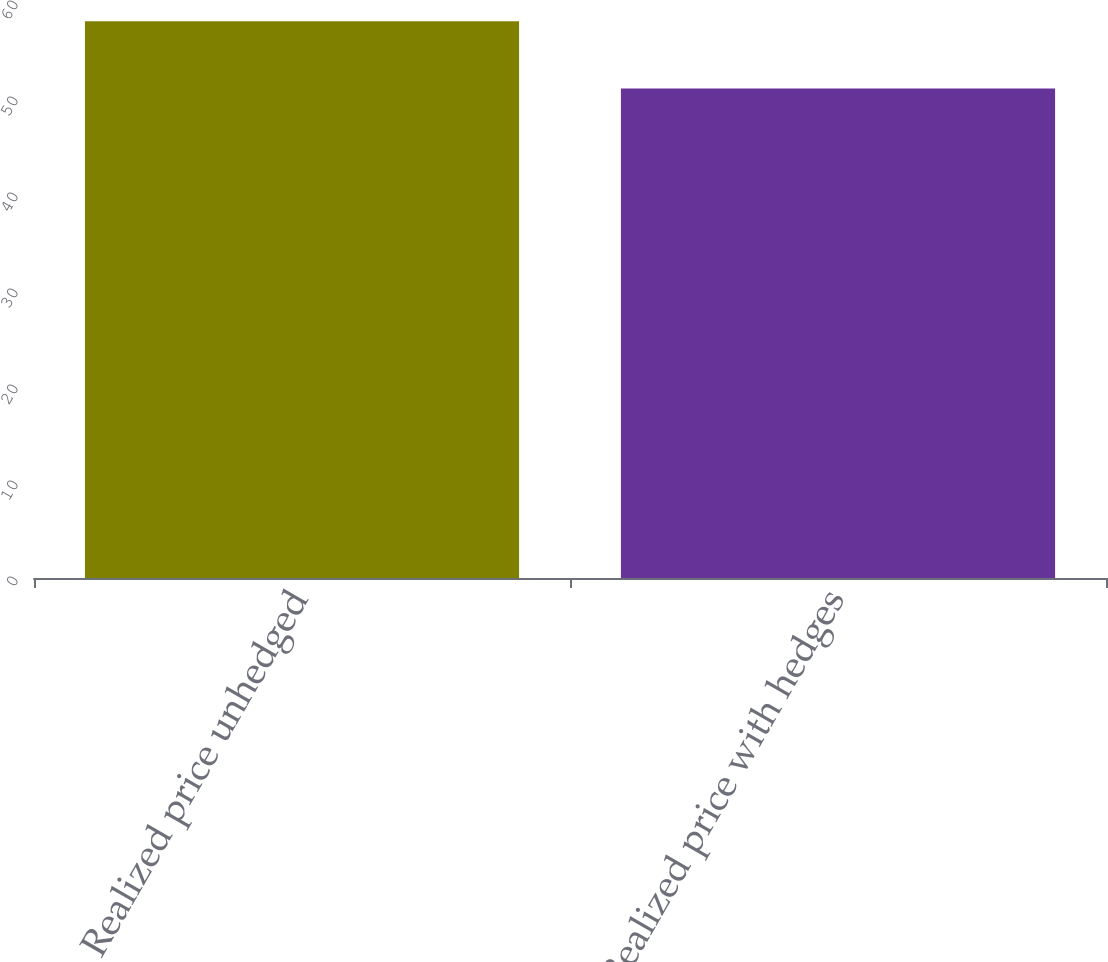<chart> <loc_0><loc_0><loc_500><loc_500><bar_chart><fcel>Realized price unhedged<fcel>Realized price with hedges<nl><fcel>58<fcel>51<nl></chart> 